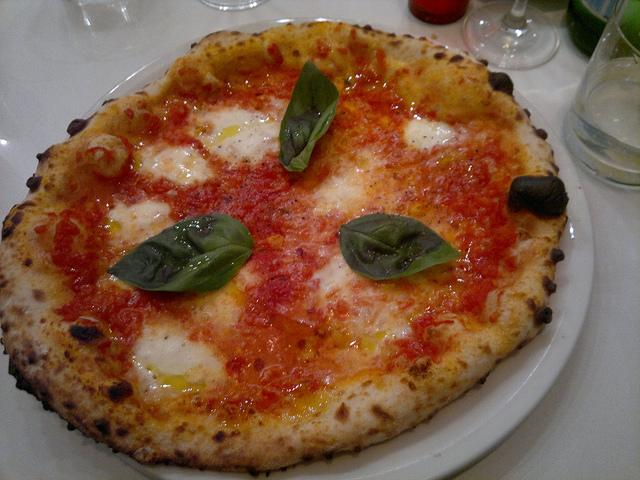Which one of these cheeses is rarely seen on this dish? cheddar 